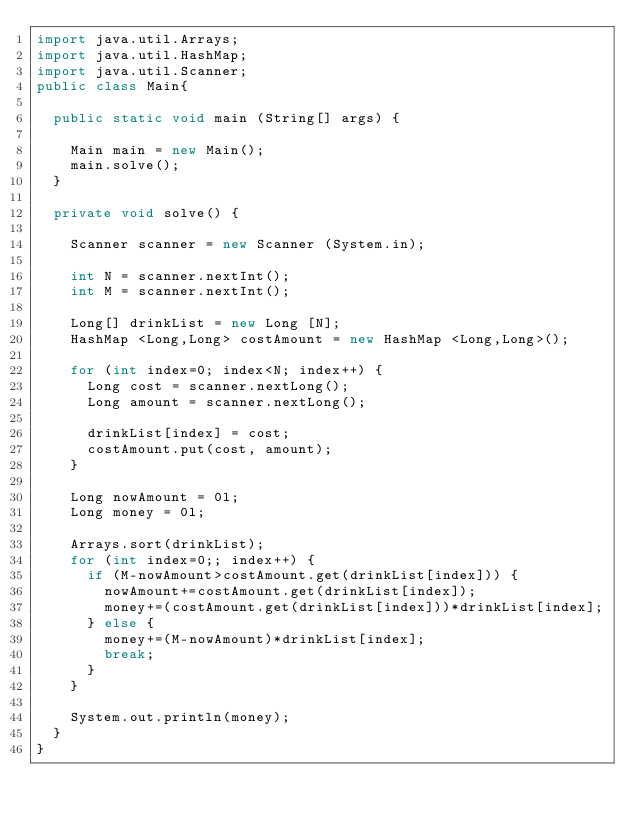<code> <loc_0><loc_0><loc_500><loc_500><_Java_>import java.util.Arrays;
import java.util.HashMap;
import java.util.Scanner;
public class Main{

	public static void main (String[] args) {

		Main main = new Main();
		main.solve();
	}

	private void solve() {

		Scanner scanner = new Scanner (System.in);

		int N = scanner.nextInt();
		int M = scanner.nextInt();

		Long[] drinkList = new Long [N];
		HashMap <Long,Long> costAmount = new HashMap <Long,Long>();

		for (int index=0; index<N; index++) {
			Long cost = scanner.nextLong();
			Long amount = scanner.nextLong();

			drinkList[index] = cost;
			costAmount.put(cost, amount);
		}

		Long nowAmount = 0l;
		Long money = 0l;

		Arrays.sort(drinkList);
		for (int index=0;; index++) {
			if (M-nowAmount>costAmount.get(drinkList[index])) {
				nowAmount+=costAmount.get(drinkList[index]);
				money+=(costAmount.get(drinkList[index]))*drinkList[index];
			} else {
				money+=(M-nowAmount)*drinkList[index];
				break;
			}
		}

		System.out.println(money);
	}
}</code> 